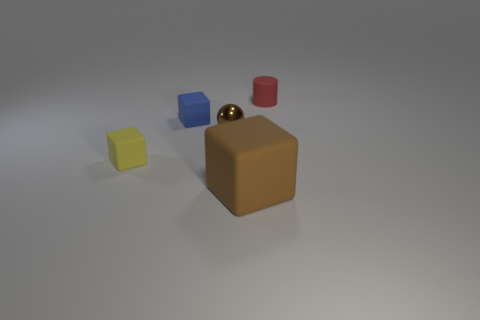Is the size of the red matte thing the same as the brown metallic ball? The red object appears to be a cylinder that is shorter in height compared to the diameter of the brown metallic sphere, implying that their sizes are not identical. Size perception might be influenced by shape and color contrasts, but a direct measurement would be needed for accurate comparison. 